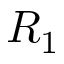Convert formula to latex. <formula><loc_0><loc_0><loc_500><loc_500>R _ { 1 }</formula> 